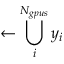Convert formula to latex. <formula><loc_0><loc_0><loc_500><loc_500>\gets \bigcup _ { i } ^ { N _ { g p u s } } y _ { i }</formula> 